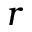Convert formula to latex. <formula><loc_0><loc_0><loc_500><loc_500>r</formula> 